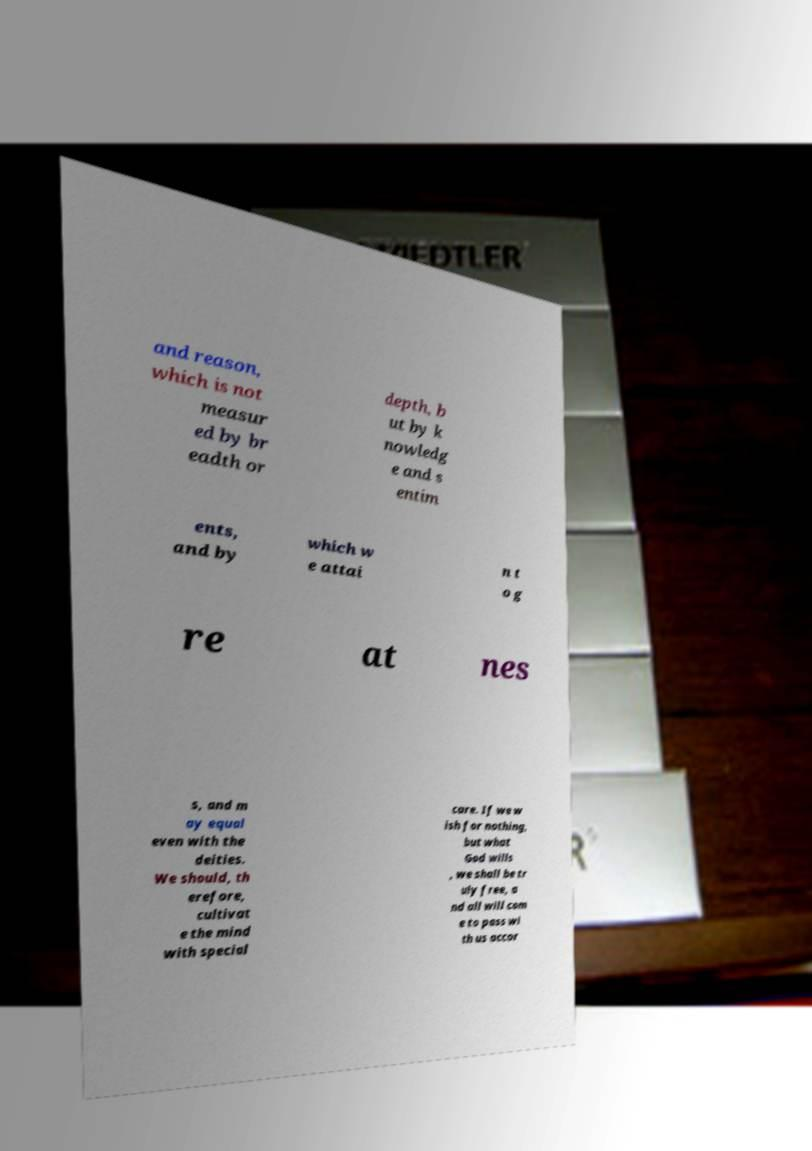Can you read and provide the text displayed in the image?This photo seems to have some interesting text. Can you extract and type it out for me? and reason, which is not measur ed by br eadth or depth, b ut by k nowledg e and s entim ents, and by which w e attai n t o g re at nes s, and m ay equal even with the deities. We should, th erefore, cultivat e the mind with special care. If we w ish for nothing, but what God wills , we shall be tr uly free, a nd all will com e to pass wi th us accor 